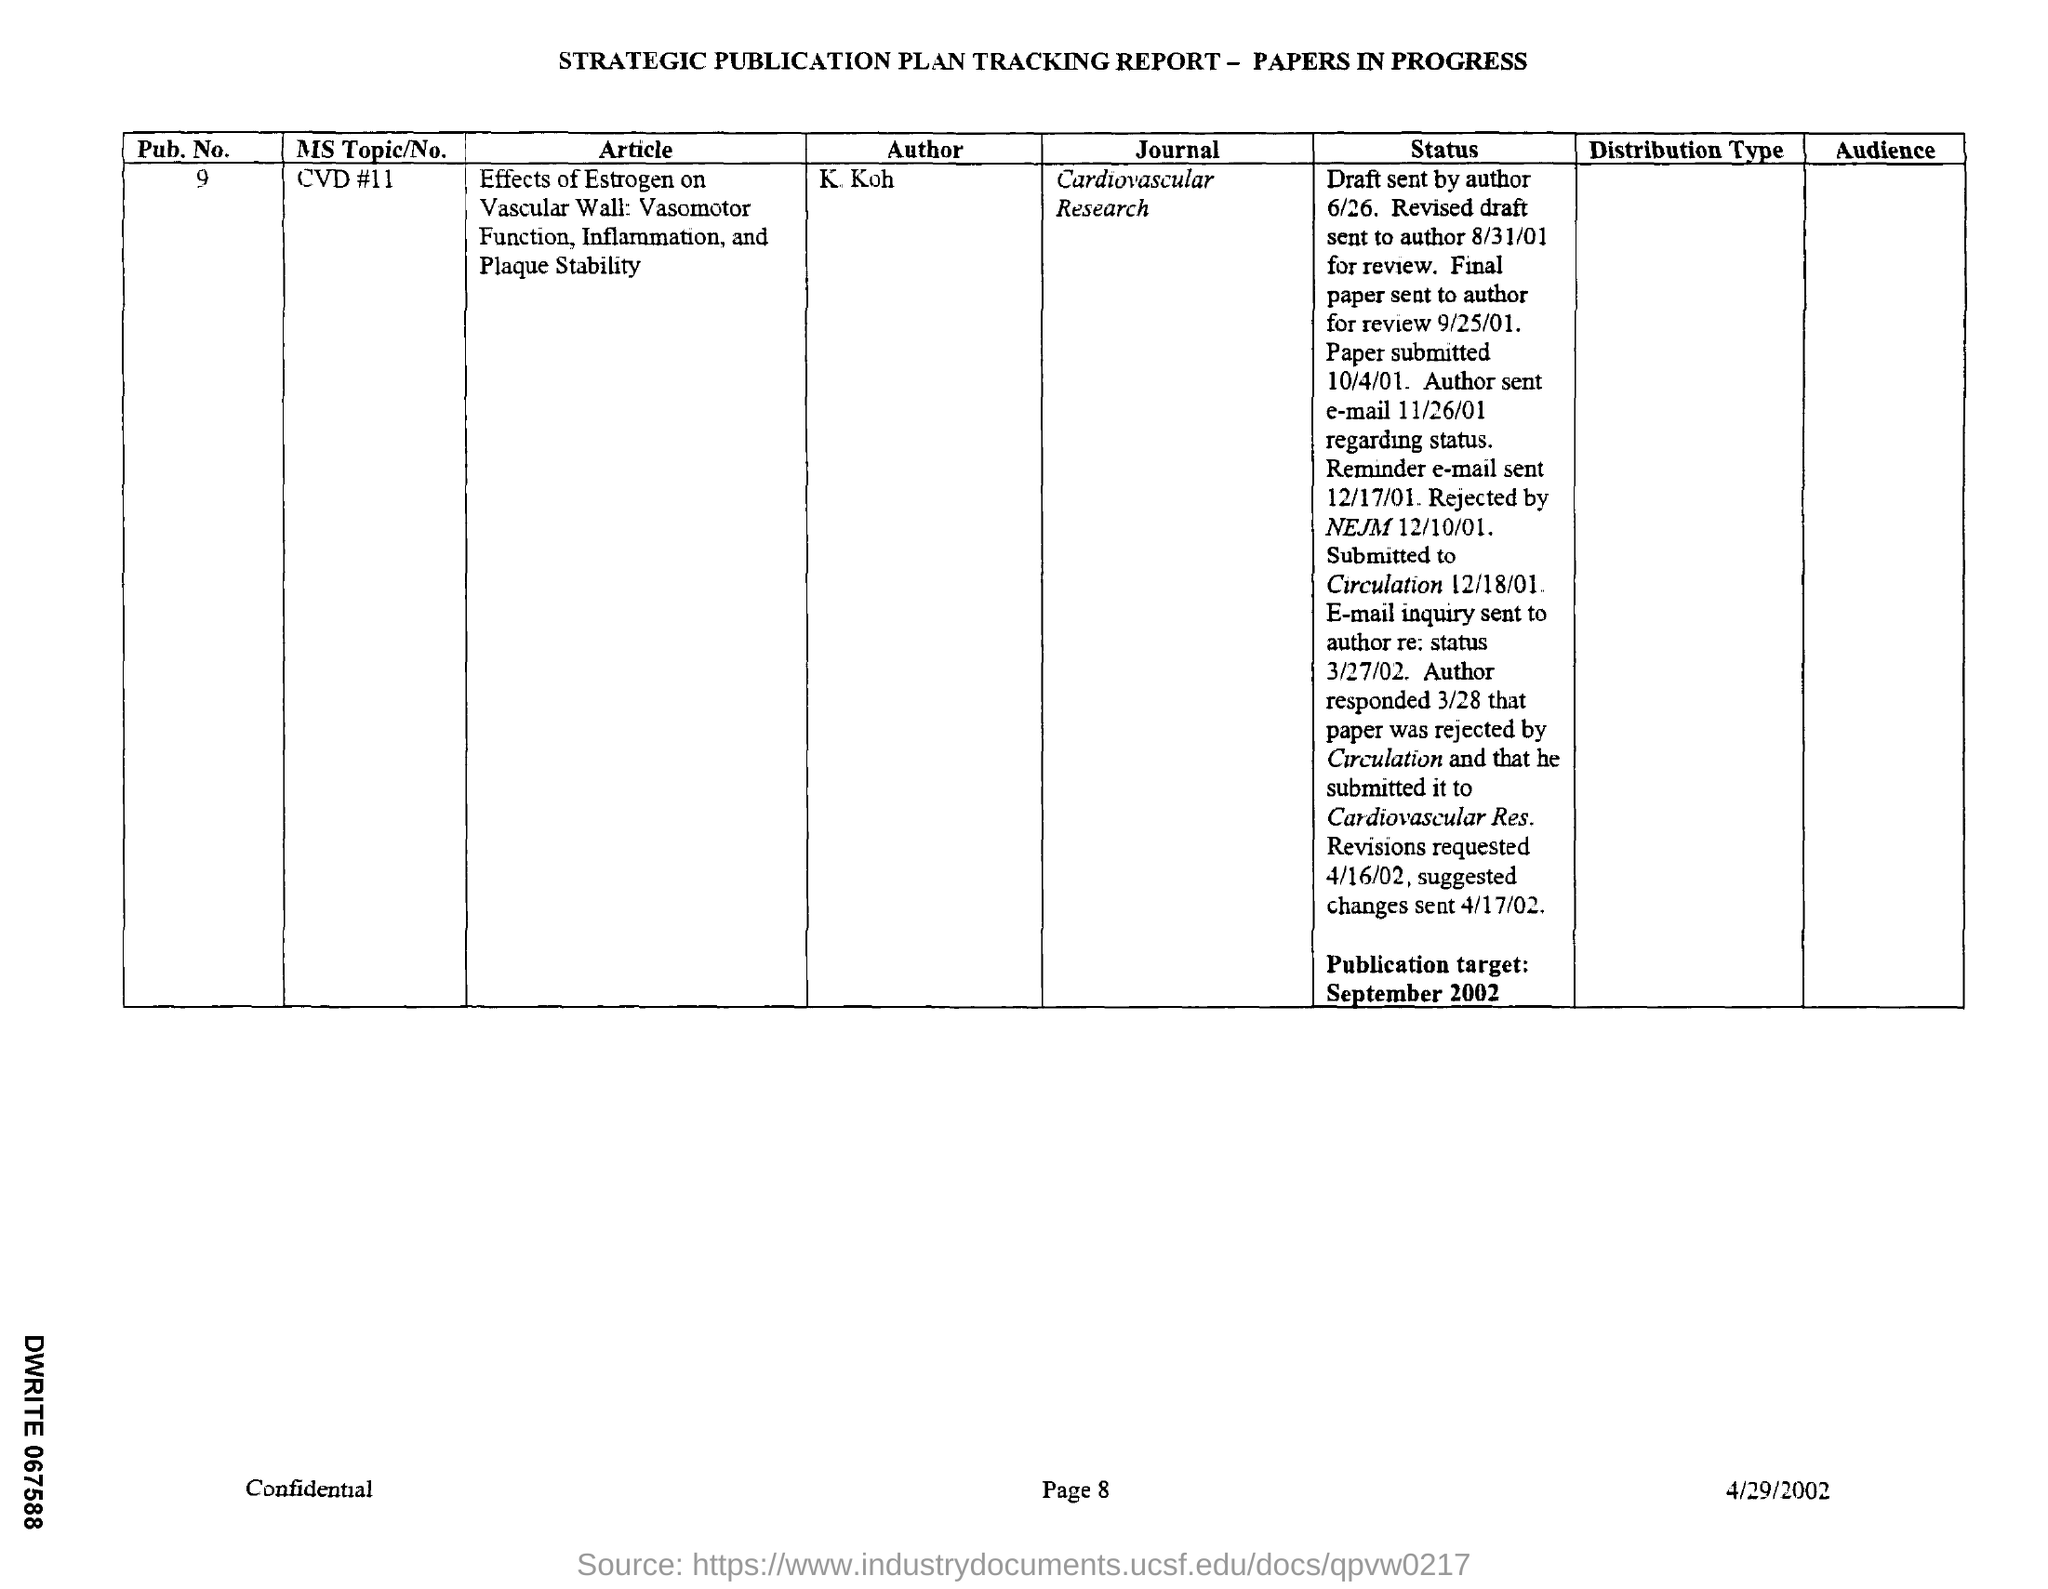What is the pub. no mentioned ?
Provide a succinct answer. 9. Who is theauthor ?
Your answer should be very brief. K.Koh. What is the name of the journal ?
Your answer should be very brief. Cardiovascular Research. When was the draft sent by author ?
Keep it short and to the point. 6/26. When was the revised draft sent to author?
Offer a very short reply. 8/31/01. When was the final paper sent to author for review ?
Offer a very short reply. 9/25/01. On which date paper was submitted ?
Make the answer very short. 10/4/01. When did the author sent an e-mail regarding status ?
Give a very brief answer. 11/26/01. When was the reminder e-mail sent ?
Offer a very short reply. 12/17/01. 